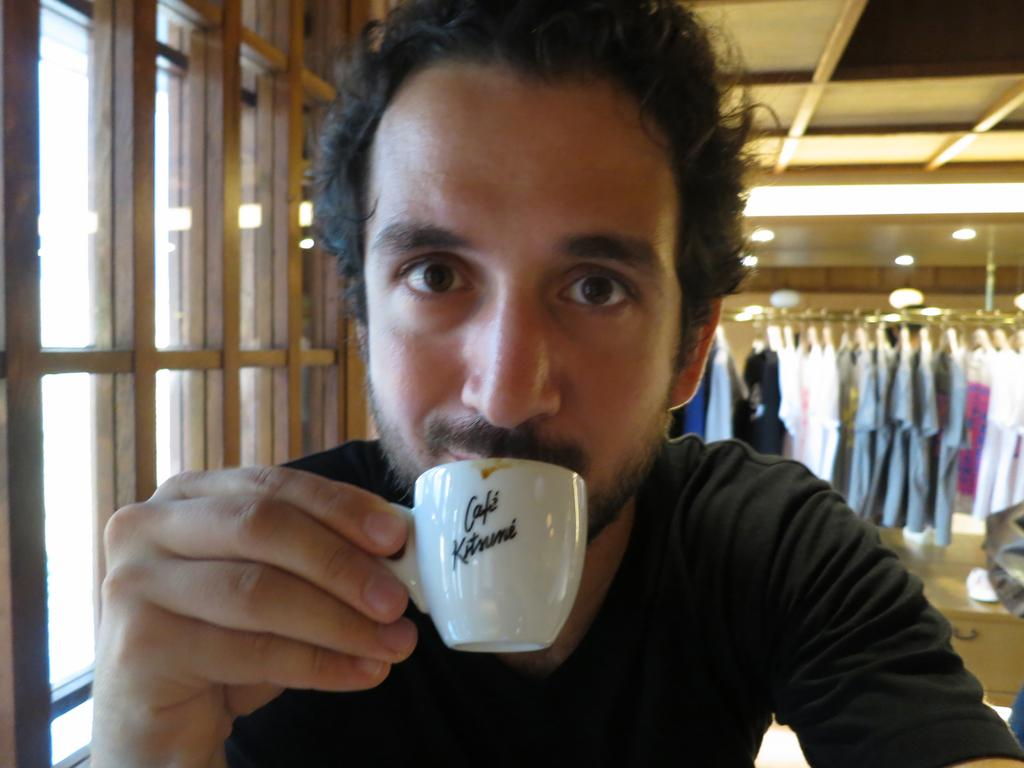What is the man in the image doing? The man is sitting in the image and sipping on a cup of coffee. What can be seen in the background of the image? There are dresses in the background of the image. What feature of the room is visible in the image? There is a window in the image. How many roses can be seen in the man's grip in the image? There are no roses present in the image, and the man is not holding anything in his grip. 